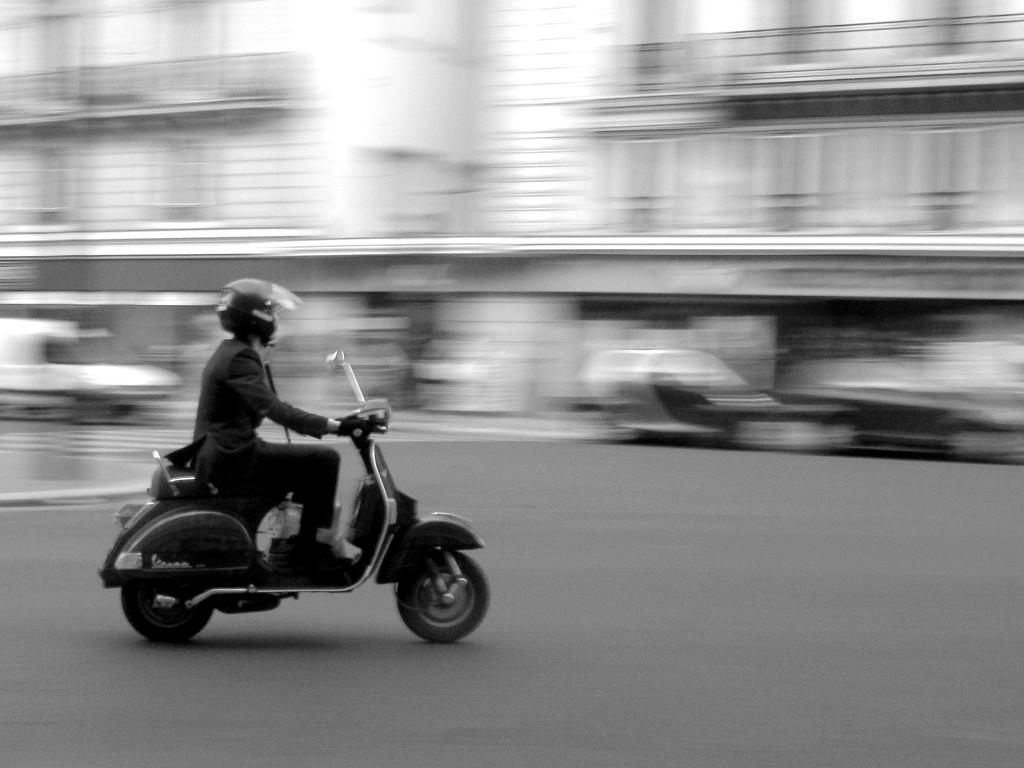What is the main subject of the image? There is a person in the image. What is the person doing in the image? The person is riding a scooter. Where is the scooter located in the image? The scooter is on the road. What type of ring can be seen on the person's finger in the image? There is no ring visible on the person's finger in the image. Is the person following the rules of the road while riding the scooter in the image? The image does not provide enough information to determine whether the person is following the rules of the road or not. 